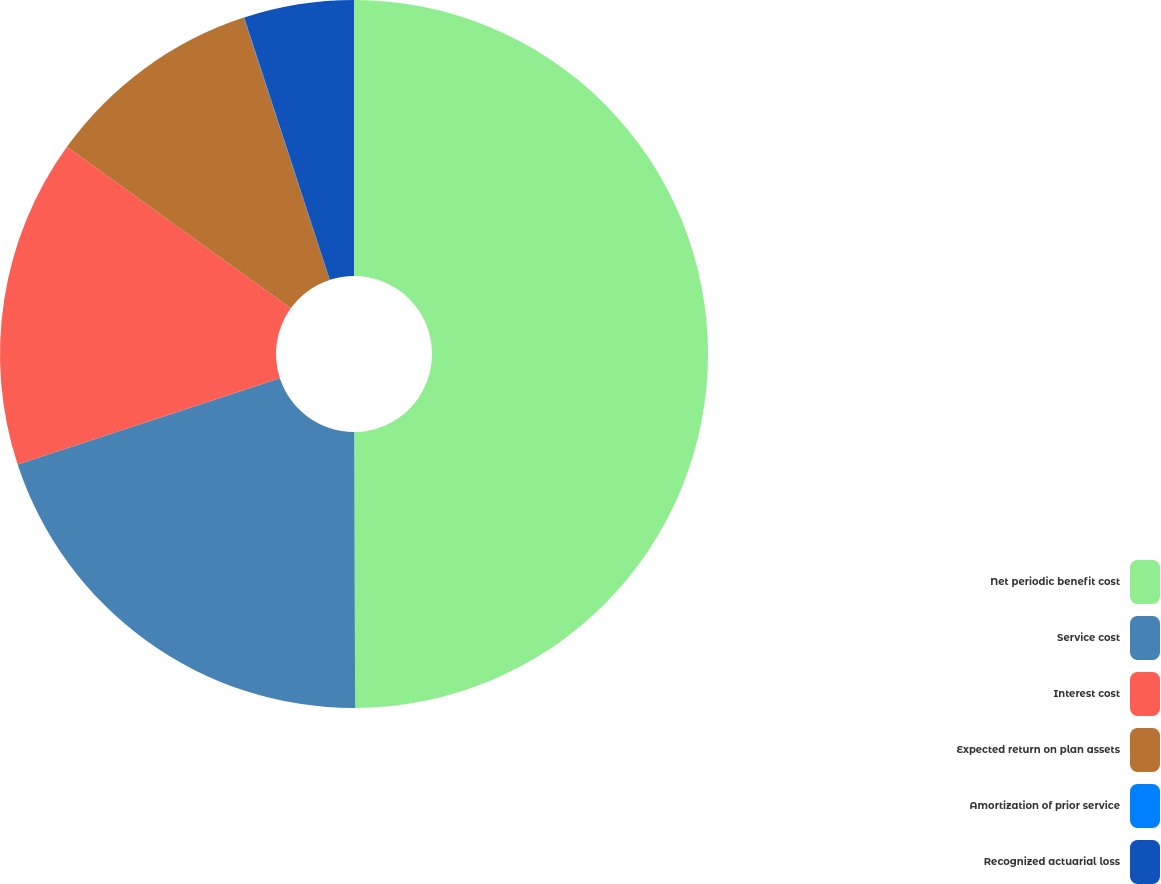Convert chart. <chart><loc_0><loc_0><loc_500><loc_500><pie_chart><fcel>Net periodic benefit cost<fcel>Service cost<fcel>Interest cost<fcel>Expected return on plan assets<fcel>Amortization of prior service<fcel>Recognized actuarial loss<nl><fcel>49.95%<fcel>20.0%<fcel>15.0%<fcel>10.01%<fcel>0.02%<fcel>5.02%<nl></chart> 